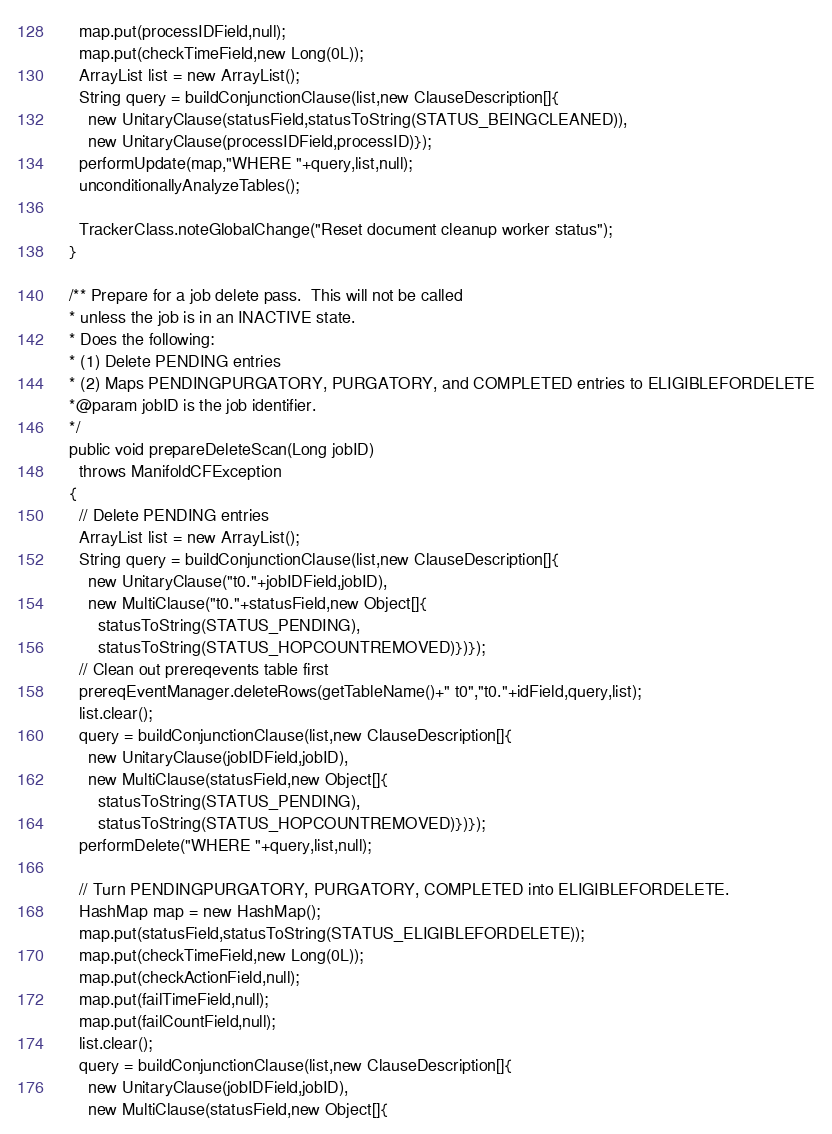<code> <loc_0><loc_0><loc_500><loc_500><_Java_>    map.put(processIDField,null);
    map.put(checkTimeField,new Long(0L));
    ArrayList list = new ArrayList();
    String query = buildConjunctionClause(list,new ClauseDescription[]{
      new UnitaryClause(statusField,statusToString(STATUS_BEINGCLEANED)),
      new UnitaryClause(processIDField,processID)});
    performUpdate(map,"WHERE "+query,list,null);
    unconditionallyAnalyzeTables();

    TrackerClass.noteGlobalChange("Reset document cleanup worker status");
  }

  /** Prepare for a job delete pass.  This will not be called
  * unless the job is in an INACTIVE state.
  * Does the following:
  * (1) Delete PENDING entries
  * (2) Maps PENDINGPURGATORY, PURGATORY, and COMPLETED entries to ELIGIBLEFORDELETE
  *@param jobID is the job identifier.
  */
  public void prepareDeleteScan(Long jobID)
    throws ManifoldCFException
  {
    // Delete PENDING entries
    ArrayList list = new ArrayList();
    String query = buildConjunctionClause(list,new ClauseDescription[]{
      new UnitaryClause("t0."+jobIDField,jobID),
      new MultiClause("t0."+statusField,new Object[]{
        statusToString(STATUS_PENDING),
        statusToString(STATUS_HOPCOUNTREMOVED)})});
    // Clean out prereqevents table first
    prereqEventManager.deleteRows(getTableName()+" t0","t0."+idField,query,list);
    list.clear();
    query = buildConjunctionClause(list,new ClauseDescription[]{
      new UnitaryClause(jobIDField,jobID),
      new MultiClause(statusField,new Object[]{
        statusToString(STATUS_PENDING),
        statusToString(STATUS_HOPCOUNTREMOVED)})});
    performDelete("WHERE "+query,list,null);

    // Turn PENDINGPURGATORY, PURGATORY, COMPLETED into ELIGIBLEFORDELETE.
    HashMap map = new HashMap();
    map.put(statusField,statusToString(STATUS_ELIGIBLEFORDELETE));
    map.put(checkTimeField,new Long(0L));
    map.put(checkActionField,null);
    map.put(failTimeField,null);
    map.put(failCountField,null);
    list.clear();
    query = buildConjunctionClause(list,new ClauseDescription[]{
      new UnitaryClause(jobIDField,jobID),
      new MultiClause(statusField,new Object[]{</code> 